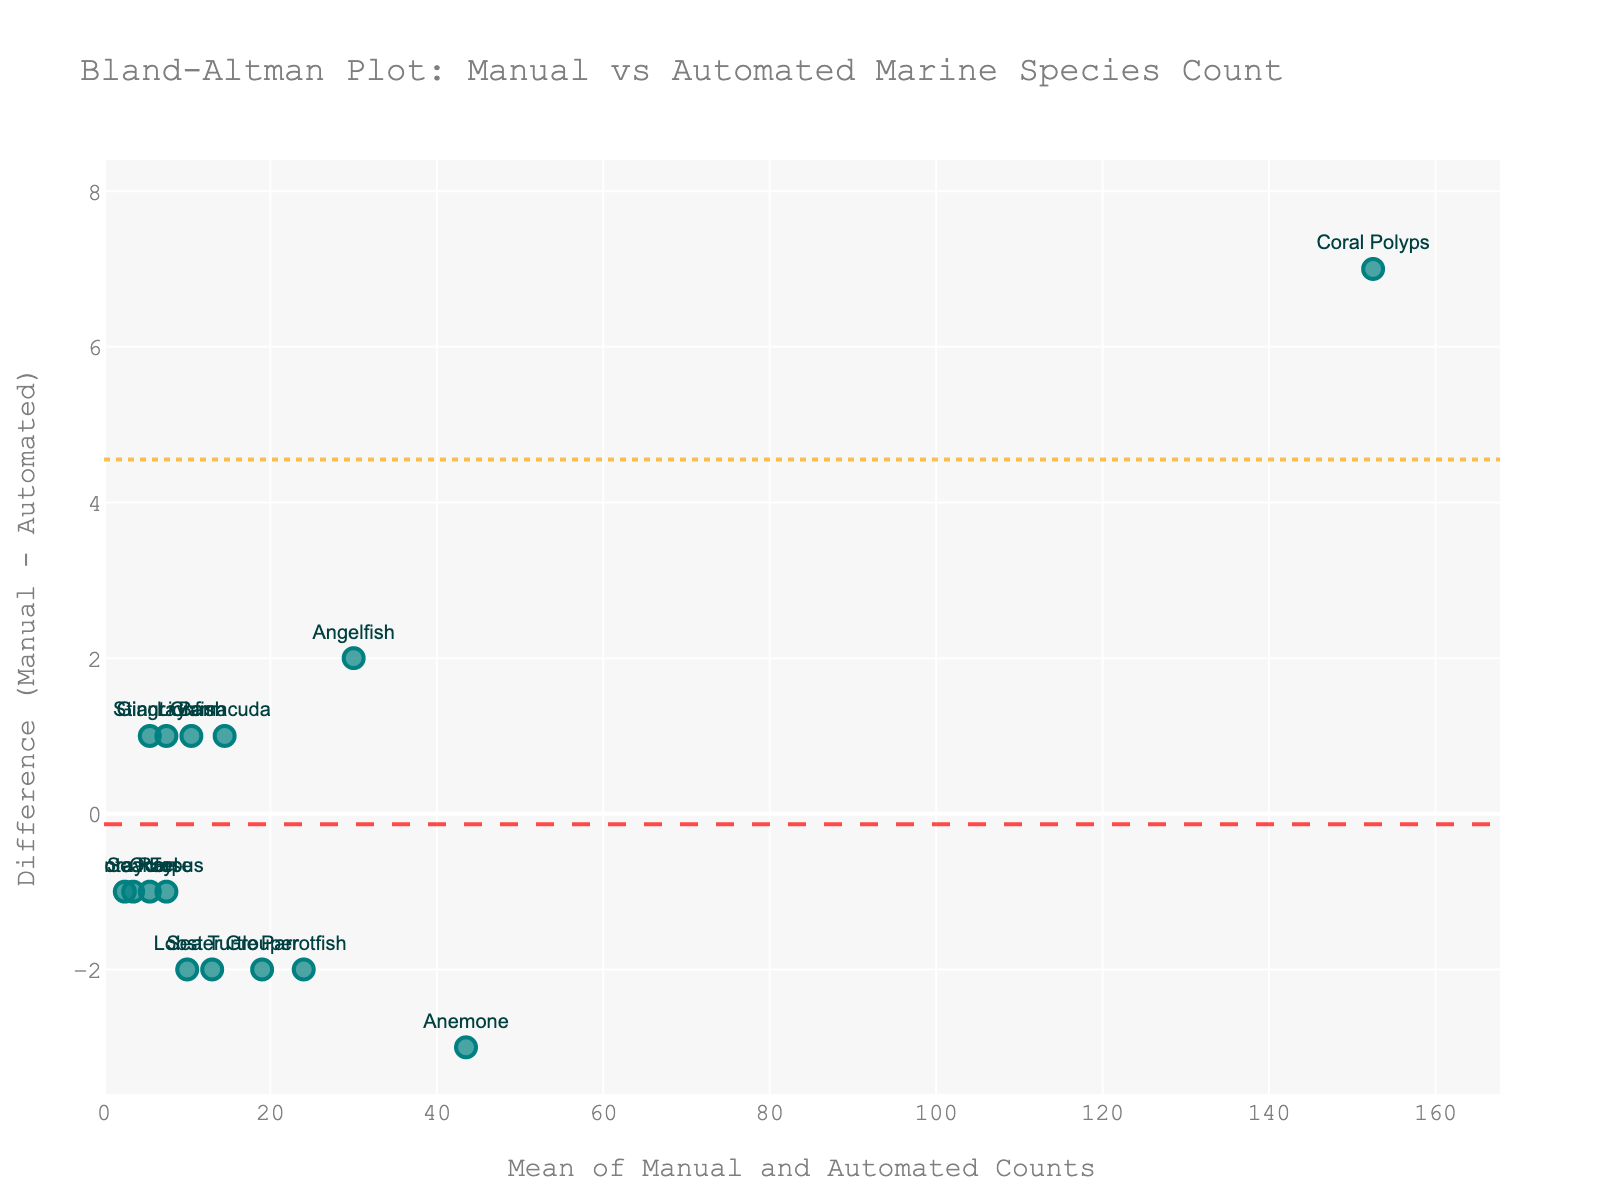How many different marine species are represented on the plot? The plot shows markers, each labeled with a different marine species name. By counting the unique species names, we can determine the number of different species present. In this case, the plot includes 15 different marine species like Sea Turtle, Coral Polyps, Parrotfish, etc.
Answer: 15 What's the average difference between the manual and automated counts for the species? By examining the plot, we use the horizontal dash line representing the mean difference. The difference is the value along the y-axis where this line is drawn. From the figure, this appears to be centered around -0.2.
Answer: -0.2 Which species has the largest positive difference between manual and automated counts? Identifying the species with the highest positive y-value involves looking for the point furthest above the zero line on the y-axis. The Grouper shows the highest positive difference.
Answer: Grouper Are there any species where the manual count is consistently higher than the automated count? Positive differences indicate manual counts are higher than automated. By observing points above the zero line, we find that Species like Coral Polyps, Parrotfish, and Grouper have higher manual counts.
Answer: Yes Which species has counts closest to zero difference between manual and automated counts? Identifying the species closest to the y-axis involves looking for points nearest to zero on the y-axis. The Sea Turtle has a difference closest to zero.
Answer: Sea Turtle What's the range of average counts (manual and automated)? This involves identifying the minimum and maximum of the mean values on the x-axis. By visually estimating from the plot, the smallest mean is for Manta Ray and largest for Coral Polyps, yielding a range.
Answer: 2.5 to 152.5 Which species have a negative difference in their counts? Negative differences, where the manual count is less than the automated, are points below the zero line. Species like Anemone, Stingray, and Lionfish fall into this category.
Answer: Anemone, Stingray, Lionfish What does the dashed line represent on this plot? In a Bland–Altman plot, the dashed line typically represents the mean difference between the two methods being compared. It’s placed at the average difference value across all species.
Answer: Mean difference How many species are within the 95% limits of agreement? This involves counting the data points within the two dotted lines, which indicate the 95% confidence interval. By assessing the data points between these lines visually, most data points fall within this range except possibly a few outliers.
Answer: 13 Is there evidence of systematic bias in this plot? Systematic bias is indicated if the mean difference (dashed line) is significantly different from zero. In the plot, the mean difference is close to zero (-0.2), suggesting minimal systematic bias.
Answer: Minimal systematic bias 